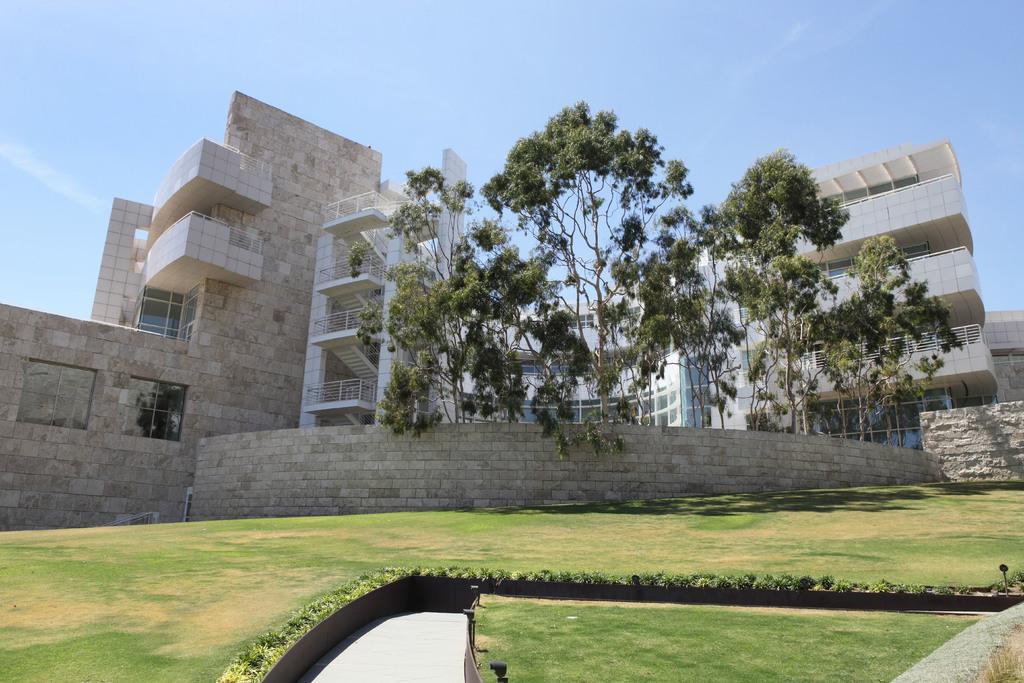Please provide a concise description of this image. In this image we can see land full of grass and buildings, trees are present. 